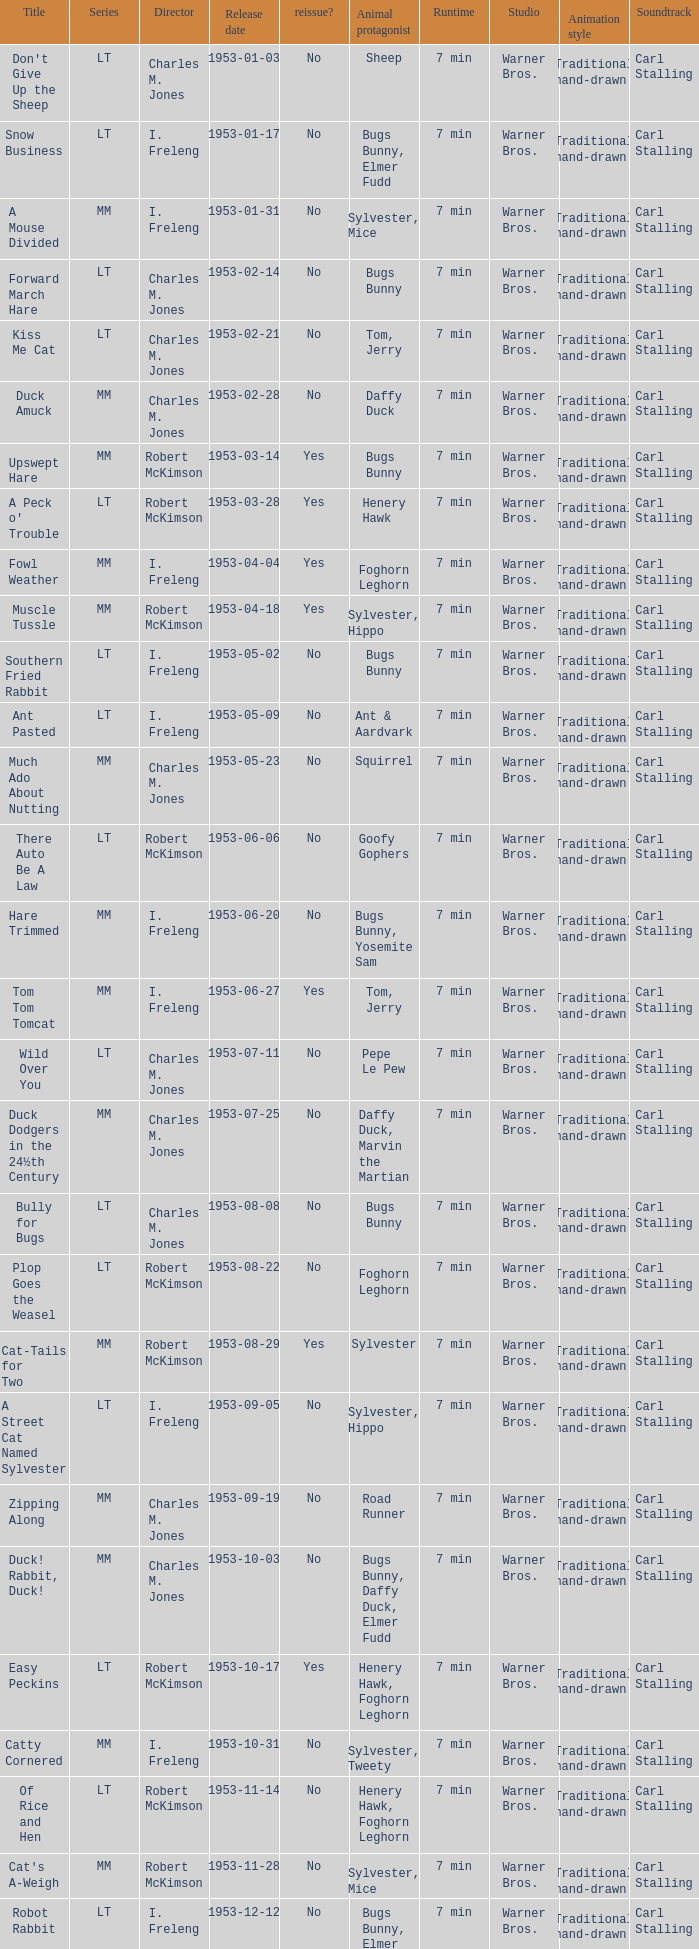Would you mind parsing the complete table? {'header': ['Title', 'Series', 'Director', 'Release date', 'reissue?', 'Animal protagonist', 'Runtime', 'Studio', 'Animation style', 'Soundtrack'], 'rows': [["Don't Give Up the Sheep", 'LT', 'Charles M. Jones', '1953-01-03', 'No', 'Sheep', '7 min', 'Warner Bros.', 'Traditional hand-drawn', 'Carl Stalling'], ['Snow Business', 'LT', 'I. Freleng', '1953-01-17', 'No', 'Bugs Bunny, Elmer Fudd', '7 min', 'Warner Bros.', 'Traditional hand-drawn', 'Carl Stalling'], ['A Mouse Divided', 'MM', 'I. Freleng', '1953-01-31', 'No', 'Sylvester, Mice', '7 min', 'Warner Bros.', 'Traditional hand-drawn', 'Carl Stalling'], ['Forward March Hare', 'LT', 'Charles M. Jones', '1953-02-14', 'No', 'Bugs Bunny', '7 min', 'Warner Bros.', 'Traditional hand-drawn', 'Carl Stalling'], ['Kiss Me Cat', 'LT', 'Charles M. Jones', '1953-02-21', 'No', 'Tom, Jerry', '7 min', 'Warner Bros.', 'Traditional hand-drawn', 'Carl Stalling'], ['Duck Amuck', 'MM', 'Charles M. Jones', '1953-02-28', 'No', 'Daffy Duck', '7 min', 'Warner Bros.', 'Traditional hand-drawn', 'Carl Stalling'], ['Upswept Hare', 'MM', 'Robert McKimson', '1953-03-14', 'Yes', 'Bugs Bunny', '7 min', 'Warner Bros.', 'Traditional hand-drawn', 'Carl Stalling'], ["A Peck o' Trouble", 'LT', 'Robert McKimson', '1953-03-28', 'Yes', 'Henery Hawk', '7 min', 'Warner Bros.', 'Traditional hand-drawn', 'Carl Stalling'], ['Fowl Weather', 'MM', 'I. Freleng', '1953-04-04', 'Yes', 'Foghorn Leghorn', '7 min', 'Warner Bros.', 'Traditional hand-drawn', 'Carl Stalling'], ['Muscle Tussle', 'MM', 'Robert McKimson', '1953-04-18', 'Yes', 'Sylvester, Hippo', '7 min', 'Warner Bros.', 'Traditional hand-drawn', 'Carl Stalling'], ['Southern Fried Rabbit', 'LT', 'I. Freleng', '1953-05-02', 'No', 'Bugs Bunny', '7 min', 'Warner Bros.', 'Traditional hand-drawn', 'Carl Stalling'], ['Ant Pasted', 'LT', 'I. Freleng', '1953-05-09', 'No', 'Ant & Aardvark', '7 min', 'Warner Bros.', 'Traditional hand-drawn', 'Carl Stalling'], ['Much Ado About Nutting', 'MM', 'Charles M. Jones', '1953-05-23', 'No', 'Squirrel', '7 min', 'Warner Bros.', 'Traditional hand-drawn', 'Carl Stalling'], ['There Auto Be A Law', 'LT', 'Robert McKimson', '1953-06-06', 'No', 'Goofy Gophers', '7 min', 'Warner Bros.', 'Traditional hand-drawn', 'Carl Stalling'], ['Hare Trimmed', 'MM', 'I. Freleng', '1953-06-20', 'No', 'Bugs Bunny, Yosemite Sam', '7 min', 'Warner Bros.', 'Traditional hand-drawn', 'Carl Stalling'], ['Tom Tom Tomcat', 'MM', 'I. Freleng', '1953-06-27', 'Yes', 'Tom, Jerry', '7 min', 'Warner Bros.', 'Traditional hand-drawn', 'Carl Stalling'], ['Wild Over You', 'LT', 'Charles M. Jones', '1953-07-11', 'No', 'Pepe Le Pew', '7 min', 'Warner Bros.', 'Traditional hand-drawn', 'Carl Stalling'], ['Duck Dodgers in the 24½th Century', 'MM', 'Charles M. Jones', '1953-07-25', 'No', 'Daffy Duck, Marvin the Martian', '7 min', 'Warner Bros.', 'Traditional hand-drawn', 'Carl Stalling'], ['Bully for Bugs', 'LT', 'Charles M. Jones', '1953-08-08', 'No', 'Bugs Bunny', '7 min', 'Warner Bros.', 'Traditional hand-drawn', 'Carl Stalling'], ['Plop Goes the Weasel', 'LT', 'Robert McKimson', '1953-08-22', 'No', 'Foghorn Leghorn', '7 min', 'Warner Bros.', 'Traditional hand-drawn', 'Carl Stalling'], ['Cat-Tails for Two', 'MM', 'Robert McKimson', '1953-08-29', 'Yes', 'Sylvester', '7 min', 'Warner Bros.', 'Traditional hand-drawn', 'Carl Stalling'], ['A Street Cat Named Sylvester', 'LT', 'I. Freleng', '1953-09-05', 'No', 'Sylvester, Hippo', '7 min', 'Warner Bros.', 'Traditional hand-drawn', 'Carl Stalling'], ['Zipping Along', 'MM', 'Charles M. Jones', '1953-09-19', 'No', 'Road Runner', '7 min', 'Warner Bros.', 'Traditional hand-drawn', 'Carl Stalling'], ['Duck! Rabbit, Duck!', 'MM', 'Charles M. Jones', '1953-10-03', 'No', 'Bugs Bunny, Daffy Duck, Elmer Fudd', '7 min', 'Warner Bros.', 'Traditional hand-drawn', 'Carl Stalling'], ['Easy Peckins', 'LT', 'Robert McKimson', '1953-10-17', 'Yes', 'Henery Hawk, Foghorn Leghorn', '7 min', 'Warner Bros.', 'Traditional hand-drawn', 'Carl Stalling'], ['Catty Cornered', 'MM', 'I. Freleng', '1953-10-31', 'No', 'Sylvester, Tweety', '7 min', 'Warner Bros.', 'Traditional hand-drawn', 'Carl Stalling'], ['Of Rice and Hen', 'LT', 'Robert McKimson', '1953-11-14', 'No', 'Henery Hawk, Foghorn Leghorn', '7 min', 'Warner Bros.', 'Traditional hand-drawn', 'Carl Stalling'], ["Cat's A-Weigh", 'MM', 'Robert McKimson', '1953-11-28', 'No', 'Sylvester, Mice', '7 min', 'Warner Bros.', 'Traditional hand-drawn', 'Carl Stalling'], ['Robot Rabbit', 'LT', 'I. Freleng', '1953-12-12', 'No', 'Bugs Bunny, Elmer Fudd', '7 min', 'Warner Bros.', 'Traditional hand-drawn', 'Carl Stalling'], ['Punch Trunk', 'LT', 'Charles M. Jones', '1953-12-19', 'No', 'Elephant', '7 min', 'Warner Bros.', 'Traditional hand-drawn', 'Carl Stalling']]} What's the release date of Forward March Hare? 1953-02-14. 